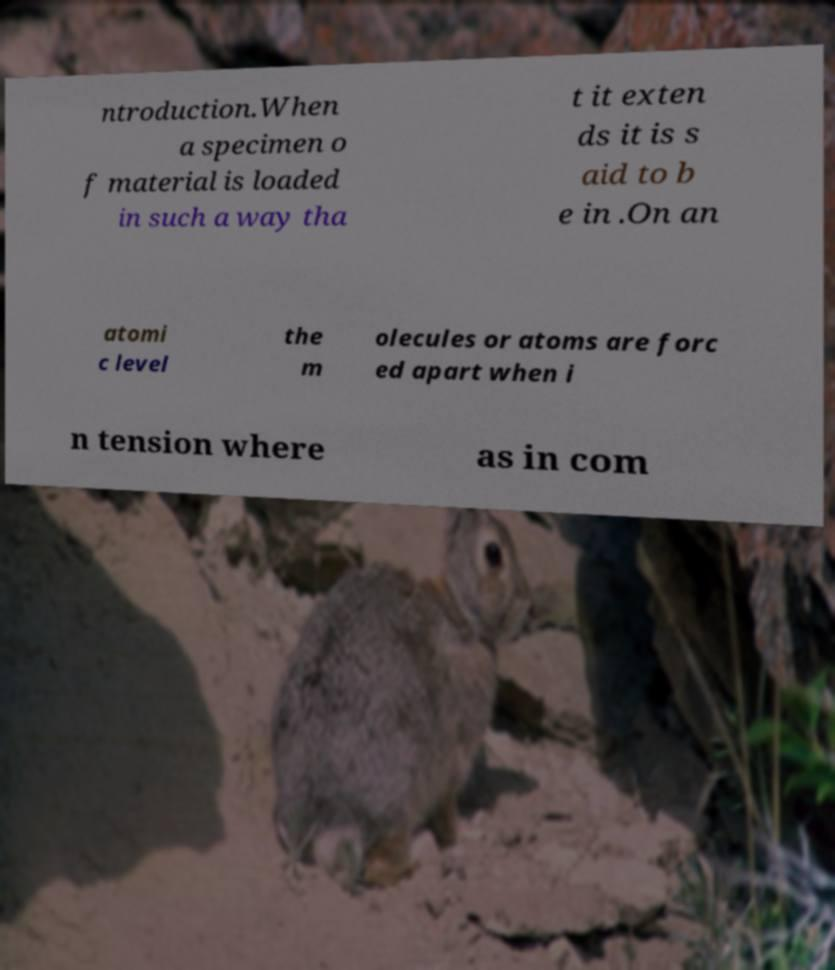What messages or text are displayed in this image? I need them in a readable, typed format. ntroduction.When a specimen o f material is loaded in such a way tha t it exten ds it is s aid to b e in .On an atomi c level the m olecules or atoms are forc ed apart when i n tension where as in com 